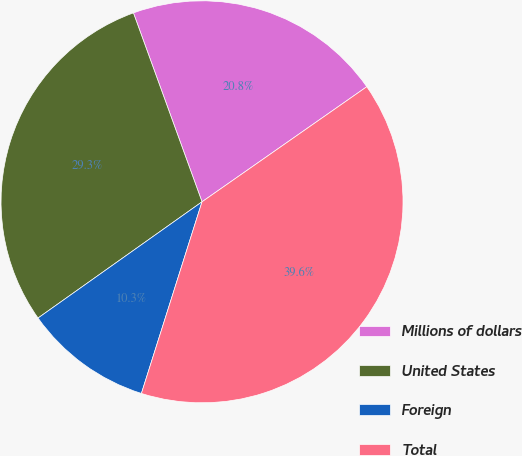<chart> <loc_0><loc_0><loc_500><loc_500><pie_chart><fcel>Millions of dollars<fcel>United States<fcel>Foreign<fcel>Total<nl><fcel>20.84%<fcel>29.27%<fcel>10.31%<fcel>39.58%<nl></chart> 